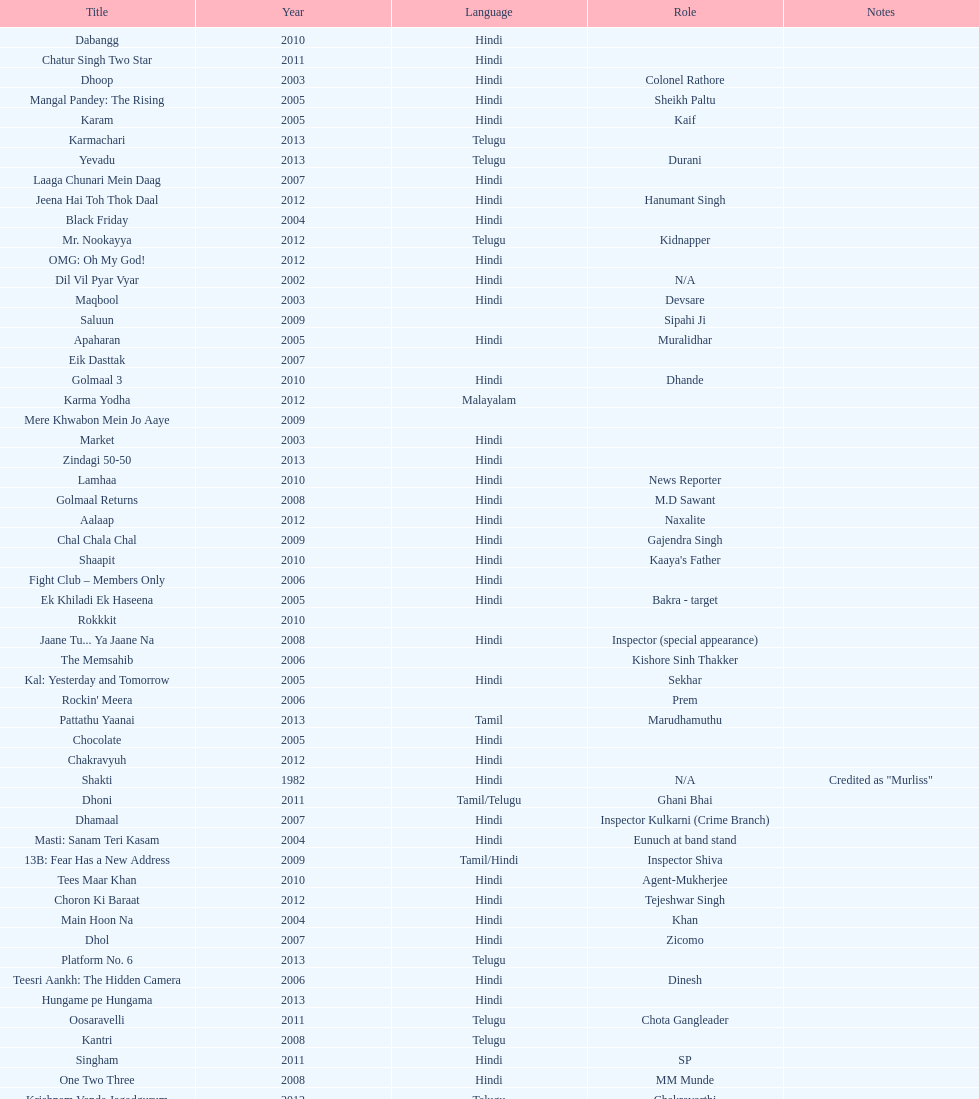What title is before dhol in 2007? Dhamaal. 